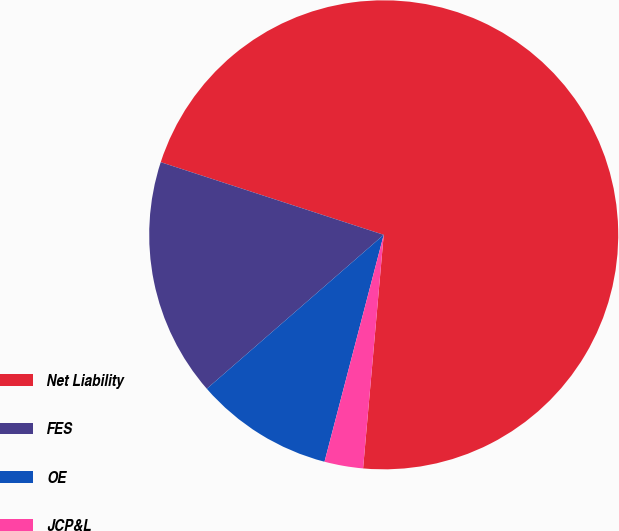<chart> <loc_0><loc_0><loc_500><loc_500><pie_chart><fcel>Net Liability<fcel>FES<fcel>OE<fcel>JCP&L<nl><fcel>71.39%<fcel>16.41%<fcel>9.54%<fcel>2.66%<nl></chart> 